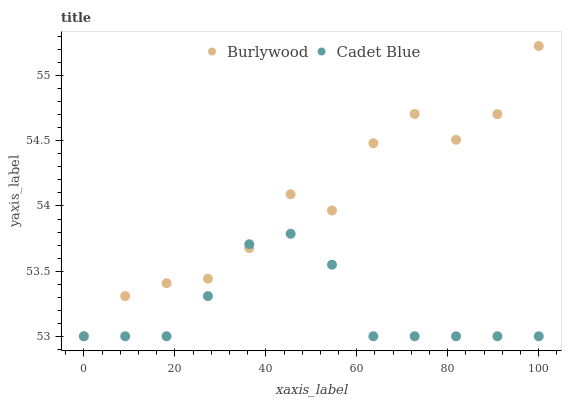Does Cadet Blue have the minimum area under the curve?
Answer yes or no. Yes. Does Burlywood have the maximum area under the curve?
Answer yes or no. Yes. Does Cadet Blue have the maximum area under the curve?
Answer yes or no. No. Is Cadet Blue the smoothest?
Answer yes or no. Yes. Is Burlywood the roughest?
Answer yes or no. Yes. Is Cadet Blue the roughest?
Answer yes or no. No. Does Burlywood have the lowest value?
Answer yes or no. Yes. Does Burlywood have the highest value?
Answer yes or no. Yes. Does Cadet Blue have the highest value?
Answer yes or no. No. Does Cadet Blue intersect Burlywood?
Answer yes or no. Yes. Is Cadet Blue less than Burlywood?
Answer yes or no. No. Is Cadet Blue greater than Burlywood?
Answer yes or no. No. 